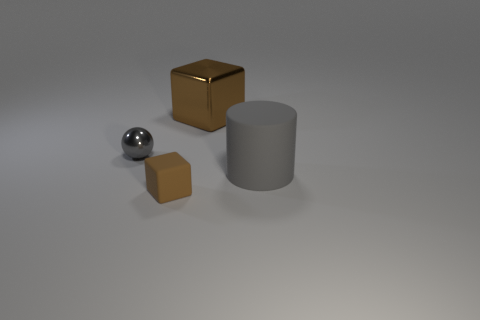There is a small brown cube that is in front of the gray rubber cylinder; what number of gray metallic spheres are to the right of it?
Your answer should be very brief. 0. Is the brown metal object the same shape as the large matte object?
Your answer should be compact. No. What size is the other rubber thing that is the same shape as the large brown thing?
Offer a very short reply. Small. What is the shape of the brown metal thing behind the matte object that is to the left of the big brown thing?
Ensure brevity in your answer.  Cube. The brown metal thing has what size?
Ensure brevity in your answer.  Large. There is a tiny brown thing; what shape is it?
Provide a short and direct response. Cube. There is a tiny gray shiny thing; is its shape the same as the rubber thing that is to the right of the brown matte block?
Make the answer very short. No. Does the small gray shiny object on the left side of the small block have the same shape as the large gray object?
Provide a short and direct response. No. What number of brown cubes are left of the brown metal cube and right of the tiny brown object?
Offer a very short reply. 0. Are there the same number of shiny balls that are in front of the large gray cylinder and large cyan metal cylinders?
Offer a terse response. Yes. 